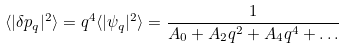<formula> <loc_0><loc_0><loc_500><loc_500>\langle | \delta p _ { q } | ^ { 2 } \rangle = q ^ { 4 } \langle | \psi _ { q } | ^ { 2 } \rangle = \frac { 1 } { A _ { 0 } + A _ { 2 } q ^ { 2 } + A _ { 4 } q ^ { 4 } + \dots }</formula> 